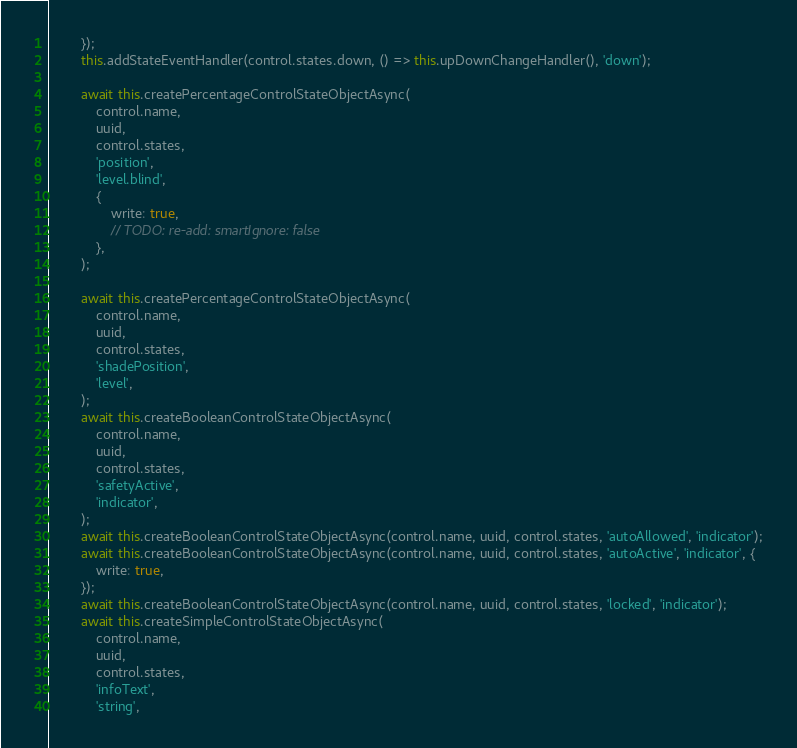Convert code to text. <code><loc_0><loc_0><loc_500><loc_500><_TypeScript_>        });
        this.addStateEventHandler(control.states.down, () => this.upDownChangeHandler(), 'down');

        await this.createPercentageControlStateObjectAsync(
            control.name,
            uuid,
            control.states,
            'position',
            'level.blind',
            {
                write: true,
                // TODO: re-add: smartIgnore: false
            },
        );

        await this.createPercentageControlStateObjectAsync(
            control.name,
            uuid,
            control.states,
            'shadePosition',
            'level',
        );
        await this.createBooleanControlStateObjectAsync(
            control.name,
            uuid,
            control.states,
            'safetyActive',
            'indicator',
        );
        await this.createBooleanControlStateObjectAsync(control.name, uuid, control.states, 'autoAllowed', 'indicator');
        await this.createBooleanControlStateObjectAsync(control.name, uuid, control.states, 'autoActive', 'indicator', {
            write: true,
        });
        await this.createBooleanControlStateObjectAsync(control.name, uuid, control.states, 'locked', 'indicator');
        await this.createSimpleControlStateObjectAsync(
            control.name,
            uuid,
            control.states,
            'infoText',
            'string',</code> 